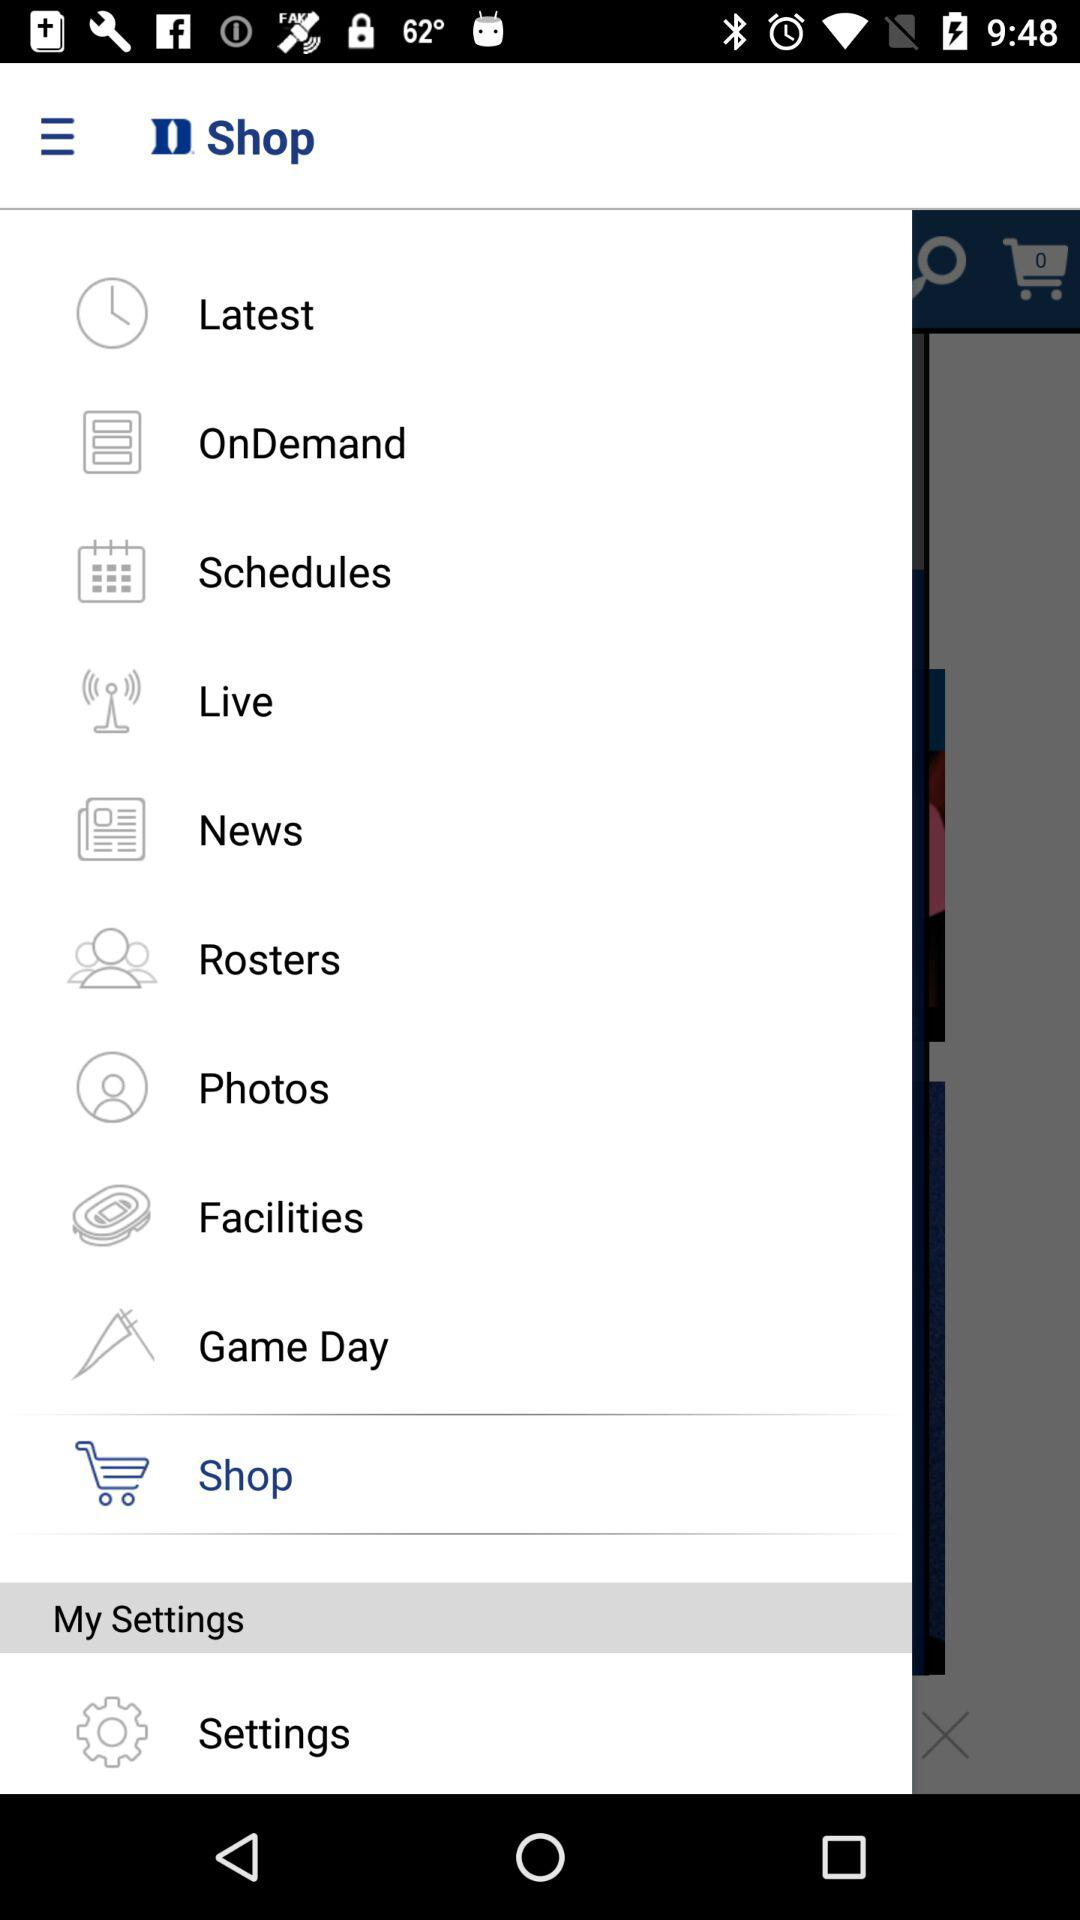Which item has been selected? The item "Shop" has been selected. 